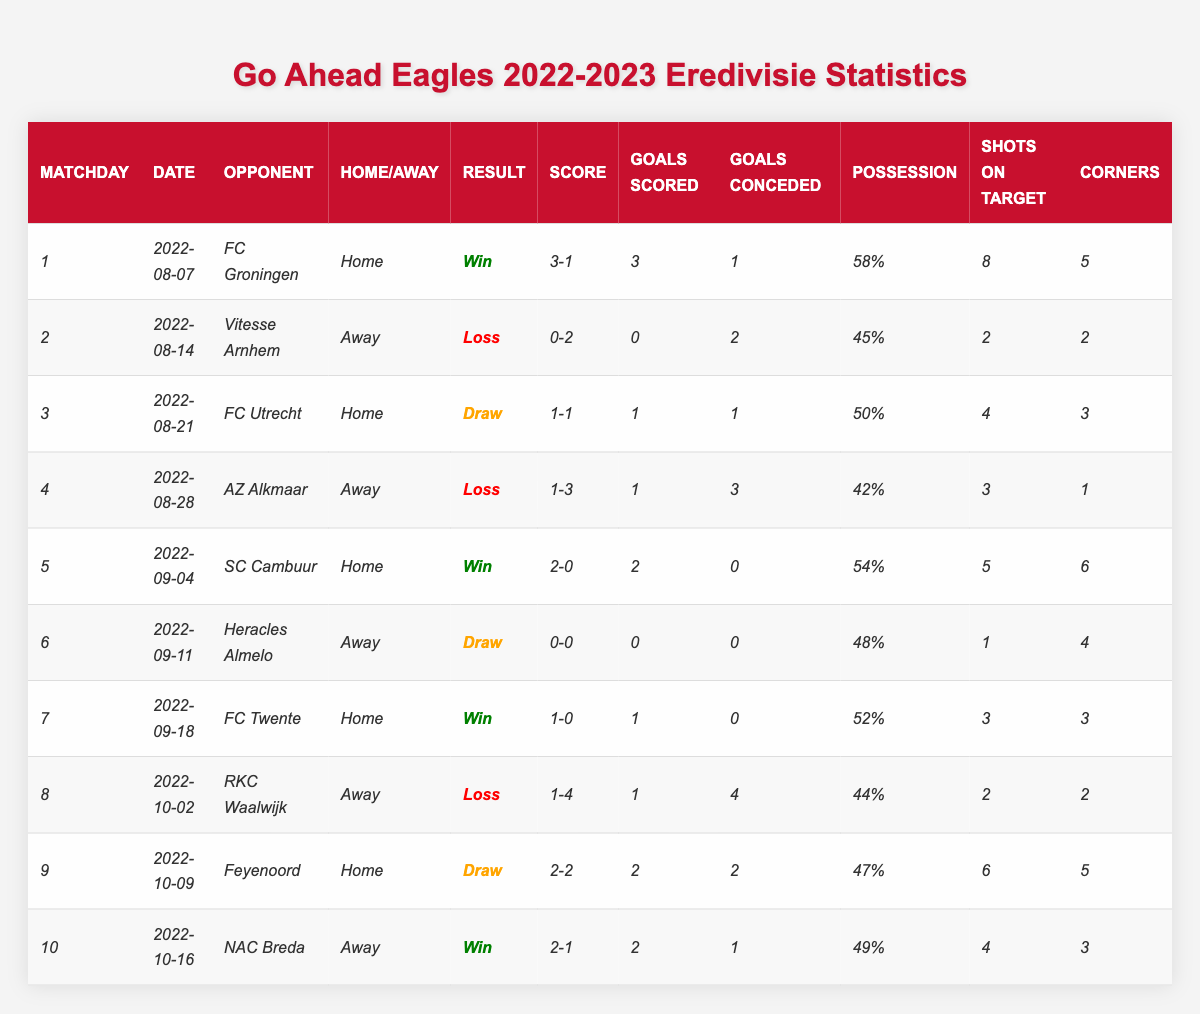What was the maximum number of goals scored by Go Ahead Eagles in a single match? The highest score recorded in the table is from the match against FC Groningen, where Go Ahead Eagles scored 3 goals. No other match shows more than 3 goals in the "Goals Scored" column.
Answer: 3 How many matches did Go Ahead Eagles win during the first 10 matchdays? The table shows that Go Ahead Eagles won matches on matchdays 1, 5, 7, and 10. This totals to 4 wins.
Answer: 4 What was the final score of the match against FC Twente? The score for the match against FC Twente is noted as 1-0 in the table.
Answer: 1-0 Did Go Ahead Eagles have more possession in their matches against SC Cambuur or AZ Alkmaar? Against SC Cambuur, possession was 54%, while against AZ Alkmaar it was 42%. Since 54% is greater than 42%, Go Ahead Eagles had more possession against SC Cambuur.
Answer: Yes, more possession against SC Cambuur What is the average number of corners taken by Go Ahead Eagles in the first 10 matches? The total number of corners from the table is: 5 + 2 + 3 + 1 + 6 + 4 + 3 + 2 + 5 + 3 = 30. Dividing this by the number of matches (10) gives us an average of 3.
Answer: 3 How many goals did Go Ahead Eagles concede in total during the first 10 matches? The total goals conceded can be calculated by adding up all the values in the "Goals Conceded" column: 1 + 2 + 1 + 3 + 0 + 0 + 0 + 4 + 2 + 1 = 14.
Answer: 14 Which match had the least number of shots on target for Go Ahead Eagles? In the match against Heracles Almelo, they had only 1 shot on target, which is the lowest recorded in the "Shots on Target" column.
Answer: Heracles Almelo Is it true that Go Ahead Eagles scored at least 2 goals in every home match? In the home matches against FC Groningen and SC Cambuur, they scored 3 and 2 goals respectively. However, in the home match against FC Utrecht, they scored only 1 goal. Therefore, the statement is false.
Answer: False What was Go Ahead Eagles' possession percentage in their most successful match? The highest possession percentage was during the match against SC Cambuur at 54%, which they won 2-0.
Answer: 54% How did Go Ahead Eagles perform at home compared to away matches? They won 3 home matches (FC Groningen, SC Cambuur, FC Twente), but only won 1 away match (NAC Breda). Overall, they had 3 wins at home versus 1 win away.
Answer: Better at home Which opponent did Go Ahead Eagles draw against and what was the score? They drew against FC Utrecht with a score of 1-1.
Answer: FC Utrecht, score 1-1 